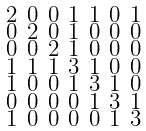<formula> <loc_0><loc_0><loc_500><loc_500>\begin{smallmatrix} 2 & 0 & 0 & 1 & 1 & 0 & 1 \\ 0 & 2 & 0 & 1 & 0 & 0 & 0 \\ 0 & 0 & 2 & 1 & 0 & 0 & 0 \\ 1 & 1 & 1 & 3 & 1 & 0 & 0 \\ 1 & 0 & 0 & 1 & 3 & 1 & 0 \\ 0 & 0 & 0 & 0 & 1 & 3 & 1 \\ 1 & 0 & 0 & 0 & 0 & 1 & 3 \end{smallmatrix}</formula> 